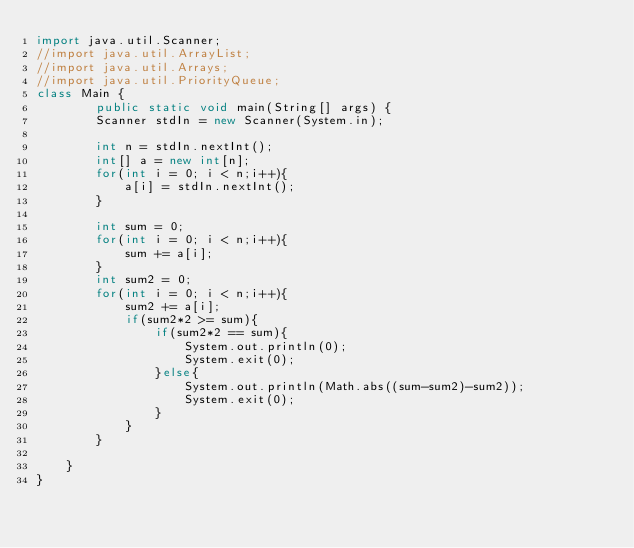<code> <loc_0><loc_0><loc_500><loc_500><_Java_>import java.util.Scanner;
//import java.util.ArrayList;
//import java.util.Arrays;
//import java.util.PriorityQueue;
class Main {
        public static void main(String[] args) {
        Scanner stdIn = new Scanner(System.in);
        
        int n = stdIn.nextInt();
        int[] a = new int[n];
        for(int i = 0; i < n;i++){
            a[i] = stdIn.nextInt();
        }

        int sum = 0;
        for(int i = 0; i < n;i++){
            sum += a[i];
        }
        int sum2 = 0;
        for(int i = 0; i < n;i++){
            sum2 += a[i];
            if(sum2*2 >= sum){
                if(sum2*2 == sum){
                    System.out.println(0);
                    System.exit(0);
                }else{
                    System.out.println(Math.abs((sum-sum2)-sum2));
                    System.exit(0);
                }
            }
        }
        
    }
}</code> 